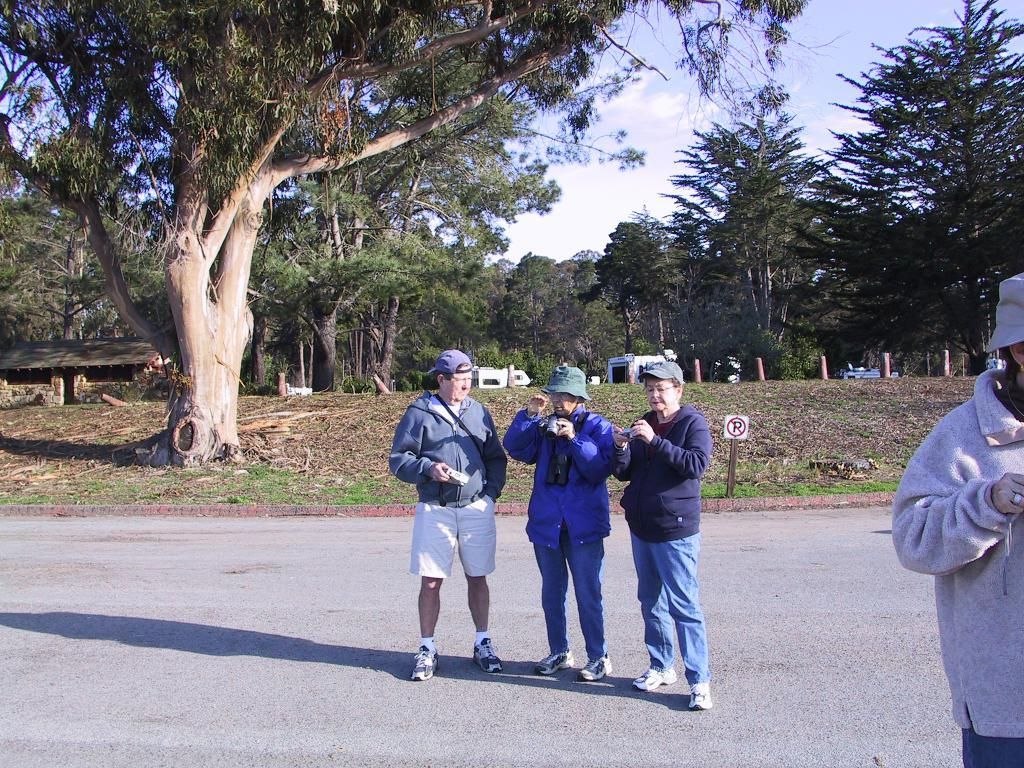What are the people in the image doing? The people in the image are standing on the road. What can be seen in the background of the image? The sky with clouds, trees, sheds, barrier poles, and a sign board are visible in the background. What is on the ground in the image? Shredded leaves are on the ground. What type of books can be seen on the people's heads in the image? There are no books present in the image; the people are standing on the road with no books visible. 